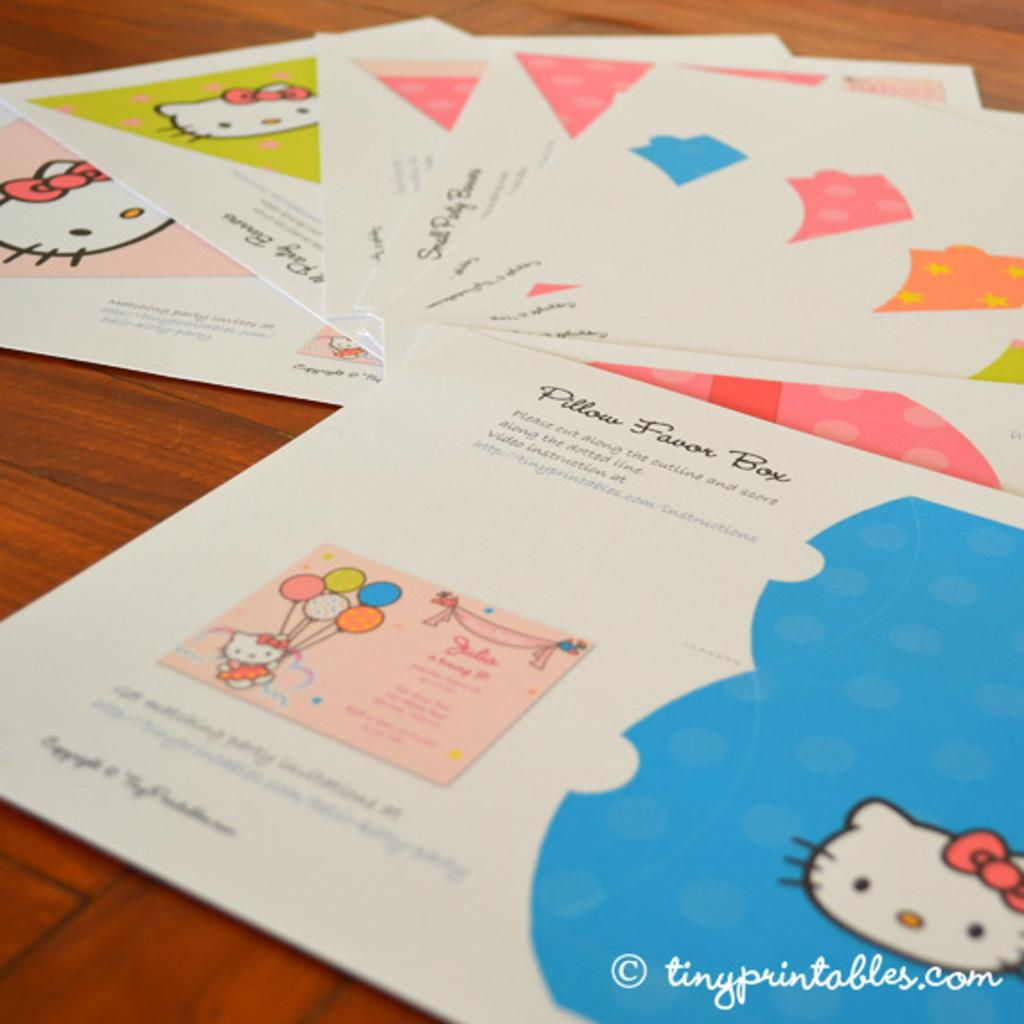<image>
Render a clear and concise summary of the photo. A set of Hello Kitty party favors with the text "Pillow Favor Box" written on the top. 